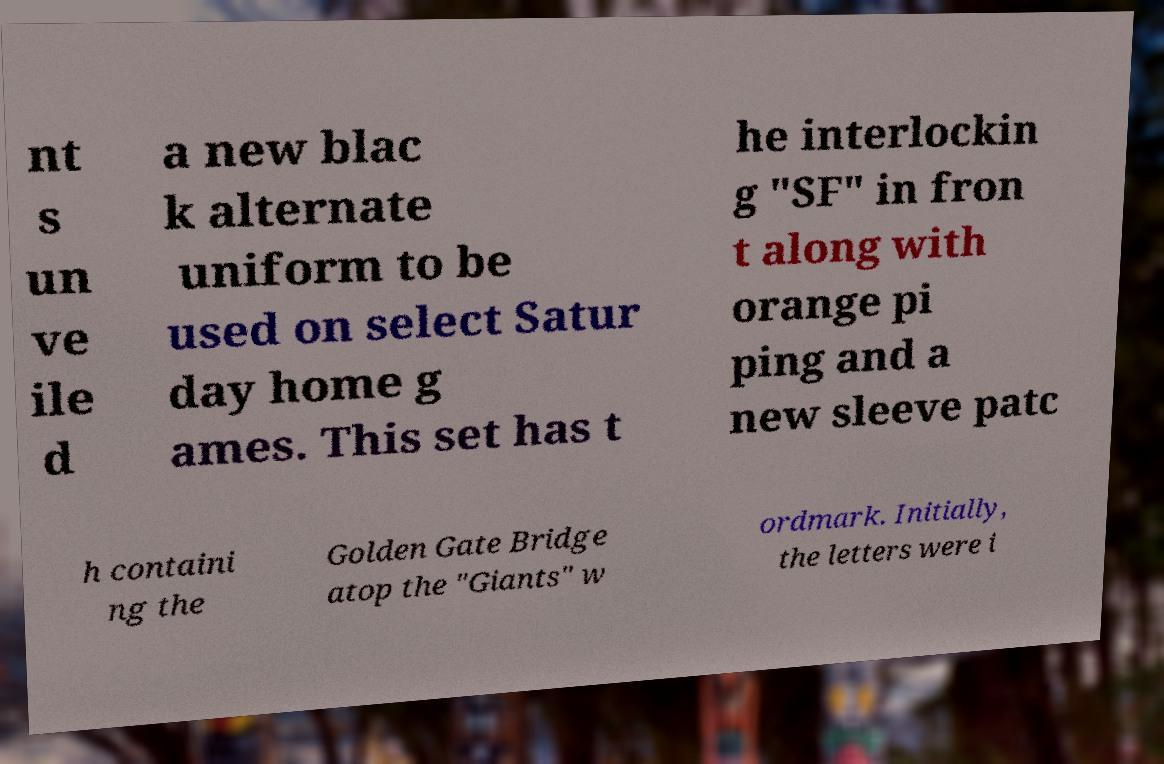Could you assist in decoding the text presented in this image and type it out clearly? nt s un ve ile d a new blac k alternate uniform to be used on select Satur day home g ames. This set has t he interlockin g "SF" in fron t along with orange pi ping and a new sleeve patc h containi ng the Golden Gate Bridge atop the "Giants" w ordmark. Initially, the letters were i 